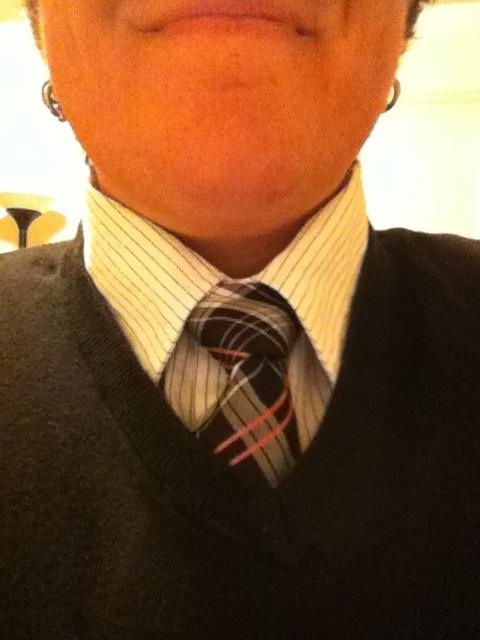Describe the objects in this image and their specific colors. I can see people in black, red, khaki, maroon, and brown tones and tie in khaki, black, maroon, and brown tones in this image. 